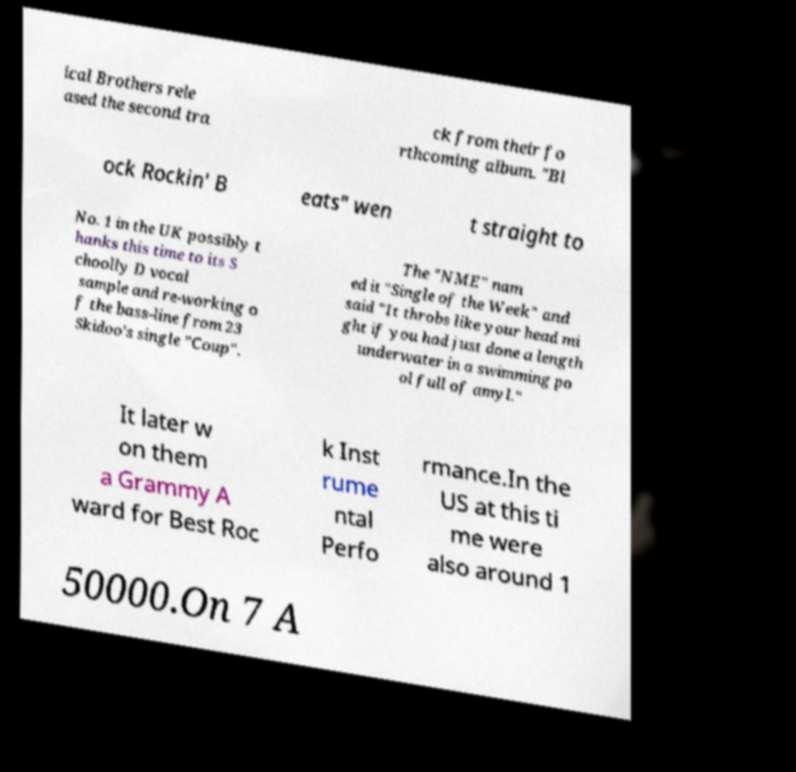What messages or text are displayed in this image? I need them in a readable, typed format. ical Brothers rele ased the second tra ck from their fo rthcoming album. "Bl ock Rockin' B eats" wen t straight to No. 1 in the UK possibly t hanks this time to its S choolly D vocal sample and re-working o f the bass-line from 23 Skidoo's single "Coup". The "NME" nam ed it "Single of the Week" and said "It throbs like your head mi ght if you had just done a length underwater in a swimming po ol full of amyl." It later w on them a Grammy A ward for Best Roc k Inst rume ntal Perfo rmance.In the US at this ti me were also around 1 50000.On 7 A 